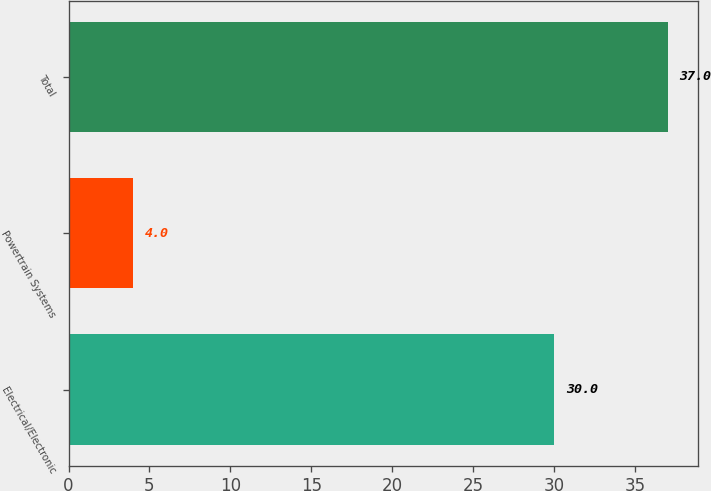<chart> <loc_0><loc_0><loc_500><loc_500><bar_chart><fcel>Electrical/Electronic<fcel>Powertrain Systems<fcel>Total<nl><fcel>30<fcel>4<fcel>37<nl></chart> 